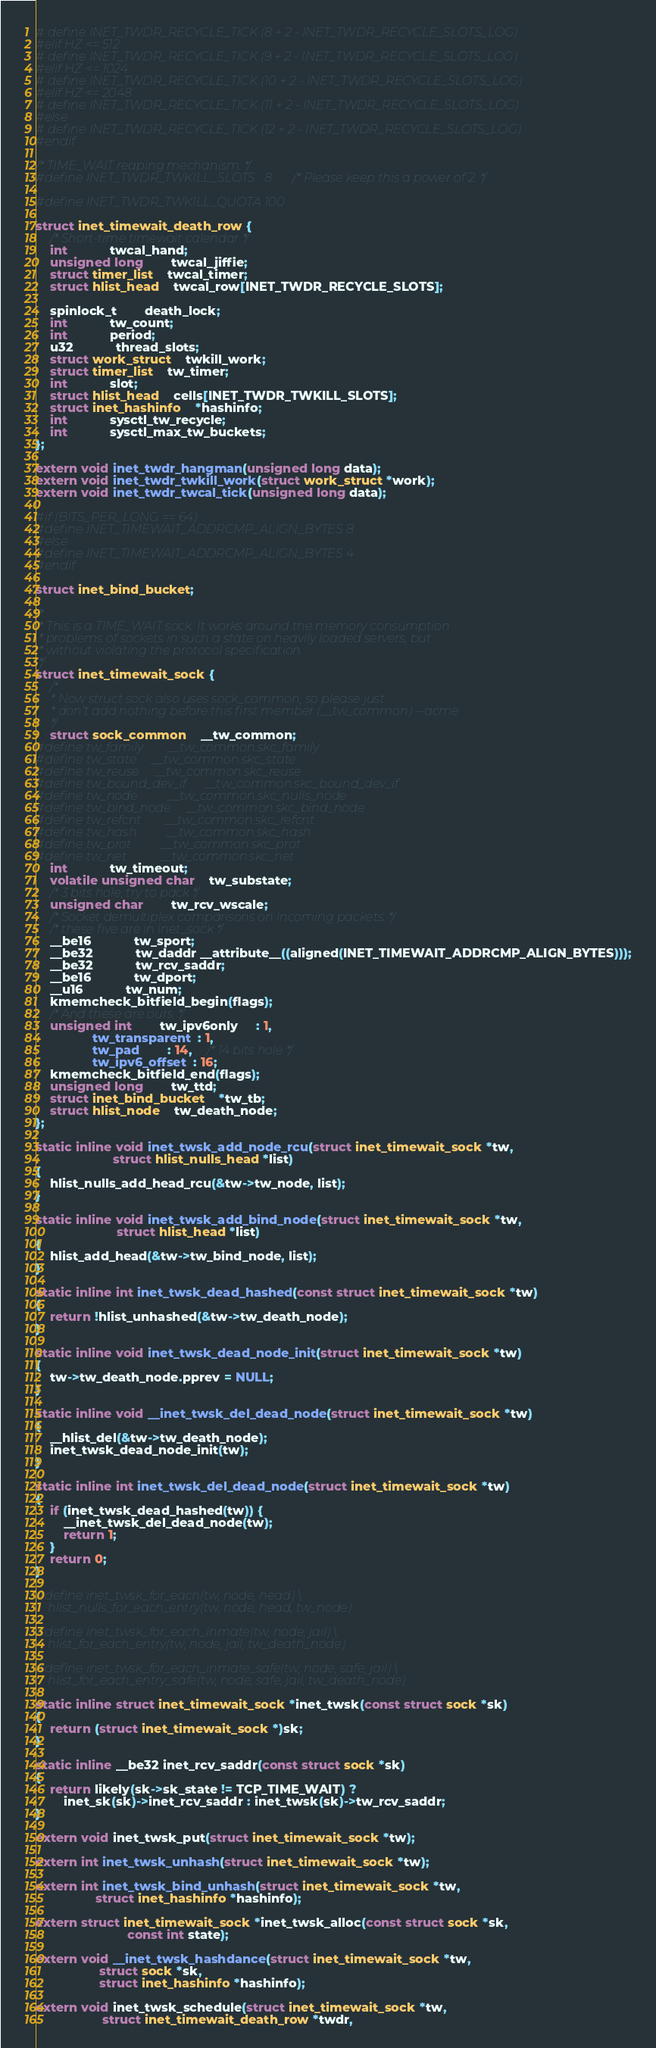<code> <loc_0><loc_0><loc_500><loc_500><_C_># define INET_TWDR_RECYCLE_TICK (8 + 2 - INET_TWDR_RECYCLE_SLOTS_LOG)
#elif HZ <= 512
# define INET_TWDR_RECYCLE_TICK (9 + 2 - INET_TWDR_RECYCLE_SLOTS_LOG)
#elif HZ <= 1024
# define INET_TWDR_RECYCLE_TICK (10 + 2 - INET_TWDR_RECYCLE_SLOTS_LOG)
#elif HZ <= 2048
# define INET_TWDR_RECYCLE_TICK (11 + 2 - INET_TWDR_RECYCLE_SLOTS_LOG)
#else
# define INET_TWDR_RECYCLE_TICK (12 + 2 - INET_TWDR_RECYCLE_SLOTS_LOG)
#endif

/* TIME_WAIT reaping mechanism. */
#define INET_TWDR_TWKILL_SLOTS	8 /* Please keep this a power of 2. */

#define INET_TWDR_TWKILL_QUOTA 100

struct inet_timewait_death_row {
	/* Short-time timewait calendar */
	int			twcal_hand;
	unsigned long		twcal_jiffie;
	struct timer_list	twcal_timer;
	struct hlist_head	twcal_row[INET_TWDR_RECYCLE_SLOTS];

	spinlock_t		death_lock;
	int			tw_count;
	int			period;
	u32			thread_slots;
	struct work_struct	twkill_work;
	struct timer_list	tw_timer;
	int			slot;
	struct hlist_head	cells[INET_TWDR_TWKILL_SLOTS];
	struct inet_hashinfo 	*hashinfo;
	int			sysctl_tw_recycle;
	int			sysctl_max_tw_buckets;
};

extern void inet_twdr_hangman(unsigned long data);
extern void inet_twdr_twkill_work(struct work_struct *work);
extern void inet_twdr_twcal_tick(unsigned long data);

#if (BITS_PER_LONG == 64)
#define INET_TIMEWAIT_ADDRCMP_ALIGN_BYTES 8
#else
#define INET_TIMEWAIT_ADDRCMP_ALIGN_BYTES 4
#endif

struct inet_bind_bucket;

/*
 * This is a TIME_WAIT sock. It works around the memory consumption
 * problems of sockets in such a state on heavily loaded servers, but
 * without violating the protocol specification.
 */
struct inet_timewait_sock {
	/*
	 * Now struct sock also uses sock_common, so please just
	 * don't add nothing before this first member (__tw_common) --acme
	 */
	struct sock_common	__tw_common;
#define tw_family		__tw_common.skc_family
#define tw_state		__tw_common.skc_state
#define tw_reuse		__tw_common.skc_reuse
#define tw_bound_dev_if		__tw_common.skc_bound_dev_if
#define tw_node			__tw_common.skc_nulls_node
#define tw_bind_node		__tw_common.skc_bind_node
#define tw_refcnt		__tw_common.skc_refcnt
#define tw_hash			__tw_common.skc_hash
#define tw_prot			__tw_common.skc_prot
#define tw_net			__tw_common.skc_net
	int			tw_timeout;
	volatile unsigned char	tw_substate;
	/* 3 bits hole, try to pack */
	unsigned char		tw_rcv_wscale;
	/* Socket demultiplex comparisons on incoming packets. */
	/* these five are in inet_sock */
	__be16			tw_sport;
	__be32			tw_daddr __attribute__((aligned(INET_TIMEWAIT_ADDRCMP_ALIGN_BYTES)));
	__be32			tw_rcv_saddr;
	__be16			tw_dport;
	__u16			tw_num;
	kmemcheck_bitfield_begin(flags);
	/* And these are ours. */
	unsigned int		tw_ipv6only     : 1,
				tw_transparent  : 1,
				tw_pad		: 14,	/* 14 bits hole */
				tw_ipv6_offset  : 16;
	kmemcheck_bitfield_end(flags);
	unsigned long		tw_ttd;
	struct inet_bind_bucket	*tw_tb;
	struct hlist_node	tw_death_node;
};

static inline void inet_twsk_add_node_rcu(struct inet_timewait_sock *tw,
				      struct hlist_nulls_head *list)
{
	hlist_nulls_add_head_rcu(&tw->tw_node, list);
}

static inline void inet_twsk_add_bind_node(struct inet_timewait_sock *tw,
					   struct hlist_head *list)
{
	hlist_add_head(&tw->tw_bind_node, list);
}

static inline int inet_twsk_dead_hashed(const struct inet_timewait_sock *tw)
{
	return !hlist_unhashed(&tw->tw_death_node);
}

static inline void inet_twsk_dead_node_init(struct inet_timewait_sock *tw)
{
	tw->tw_death_node.pprev = NULL;
}

static inline void __inet_twsk_del_dead_node(struct inet_timewait_sock *tw)
{
	__hlist_del(&tw->tw_death_node);
	inet_twsk_dead_node_init(tw);
}

static inline int inet_twsk_del_dead_node(struct inet_timewait_sock *tw)
{
	if (inet_twsk_dead_hashed(tw)) {
		__inet_twsk_del_dead_node(tw);
		return 1;
	}
	return 0;
}

#define inet_twsk_for_each(tw, node, head) \
	hlist_nulls_for_each_entry(tw, node, head, tw_node)

#define inet_twsk_for_each_inmate(tw, node, jail) \
	hlist_for_each_entry(tw, node, jail, tw_death_node)

#define inet_twsk_for_each_inmate_safe(tw, node, safe, jail) \
	hlist_for_each_entry_safe(tw, node, safe, jail, tw_death_node)

static inline struct inet_timewait_sock *inet_twsk(const struct sock *sk)
{
	return (struct inet_timewait_sock *)sk;
}

static inline __be32 inet_rcv_saddr(const struct sock *sk)
{
	return likely(sk->sk_state != TCP_TIME_WAIT) ?
		inet_sk(sk)->inet_rcv_saddr : inet_twsk(sk)->tw_rcv_saddr;
}

extern void inet_twsk_put(struct inet_timewait_sock *tw);

extern int inet_twsk_unhash(struct inet_timewait_sock *tw);

extern int inet_twsk_bind_unhash(struct inet_timewait_sock *tw,
				 struct inet_hashinfo *hashinfo);

extern struct inet_timewait_sock *inet_twsk_alloc(const struct sock *sk,
						  const int state);

extern void __inet_twsk_hashdance(struct inet_timewait_sock *tw,
				  struct sock *sk,
				  struct inet_hashinfo *hashinfo);

extern void inet_twsk_schedule(struct inet_timewait_sock *tw,
			       struct inet_timewait_death_row *twdr,</code> 